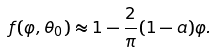Convert formula to latex. <formula><loc_0><loc_0><loc_500><loc_500>f ( \varphi , \theta _ { 0 } ) \approx 1 - \frac { 2 } { \pi } ( 1 - a ) \varphi .</formula> 